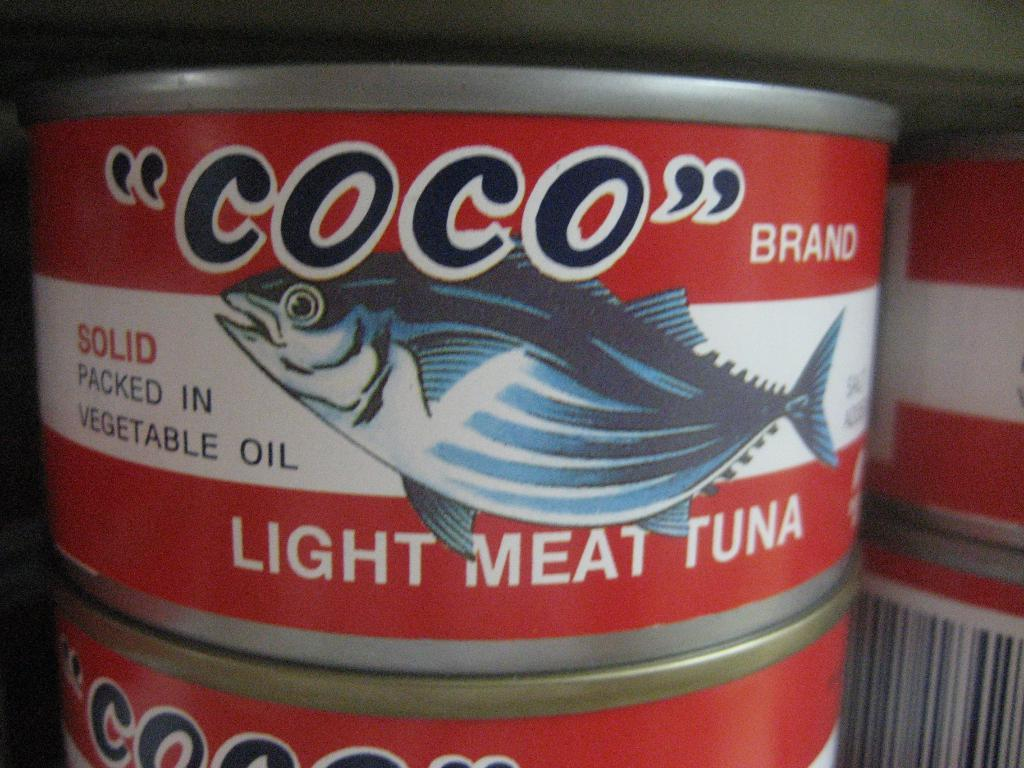<image>
Give a short and clear explanation of the subsequent image. A red and white tagged can of coco branded light meat tuna. 